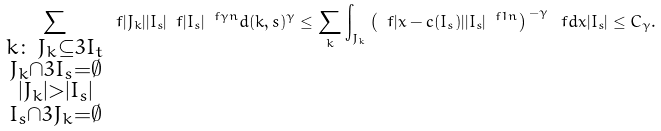Convert formula to latex. <formula><loc_0><loc_0><loc_500><loc_500>\sum _ { \substack { k \colon \, J _ { k } \subseteq 3 I _ { t } \\ J _ { k } \cap 3 I _ { s } = \emptyset \\ | J _ { k } | > | I _ { s } | \\ I _ { s } \cap 3 J _ { k } = \emptyset } } \ f { | J _ { k } | } { | I _ { s } | } \ f { | I _ { s } | ^ { \ f { \gamma } { n } } } { d ( k , s ) ^ { \gamma } } \leq \sum _ { k } \int _ { J _ { k } } \left ( \ f { | x - c ( I _ { s } ) | } { | I _ { s } | ^ { \ f 1 n } } \right ) ^ { \, - \gamma } \ f { d x } { | I _ { s } | } \leq C _ { \gamma } .</formula> 